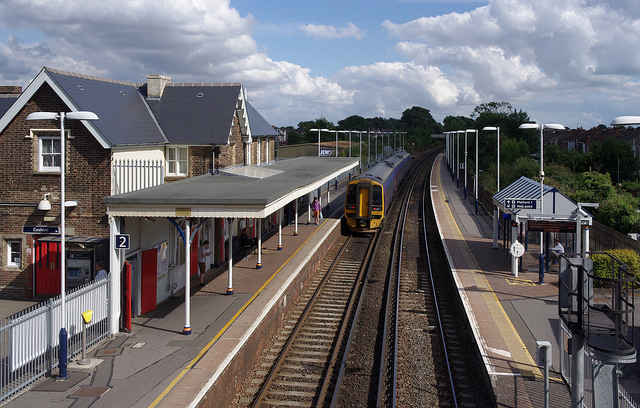Extract all visible text content from this image. 2 